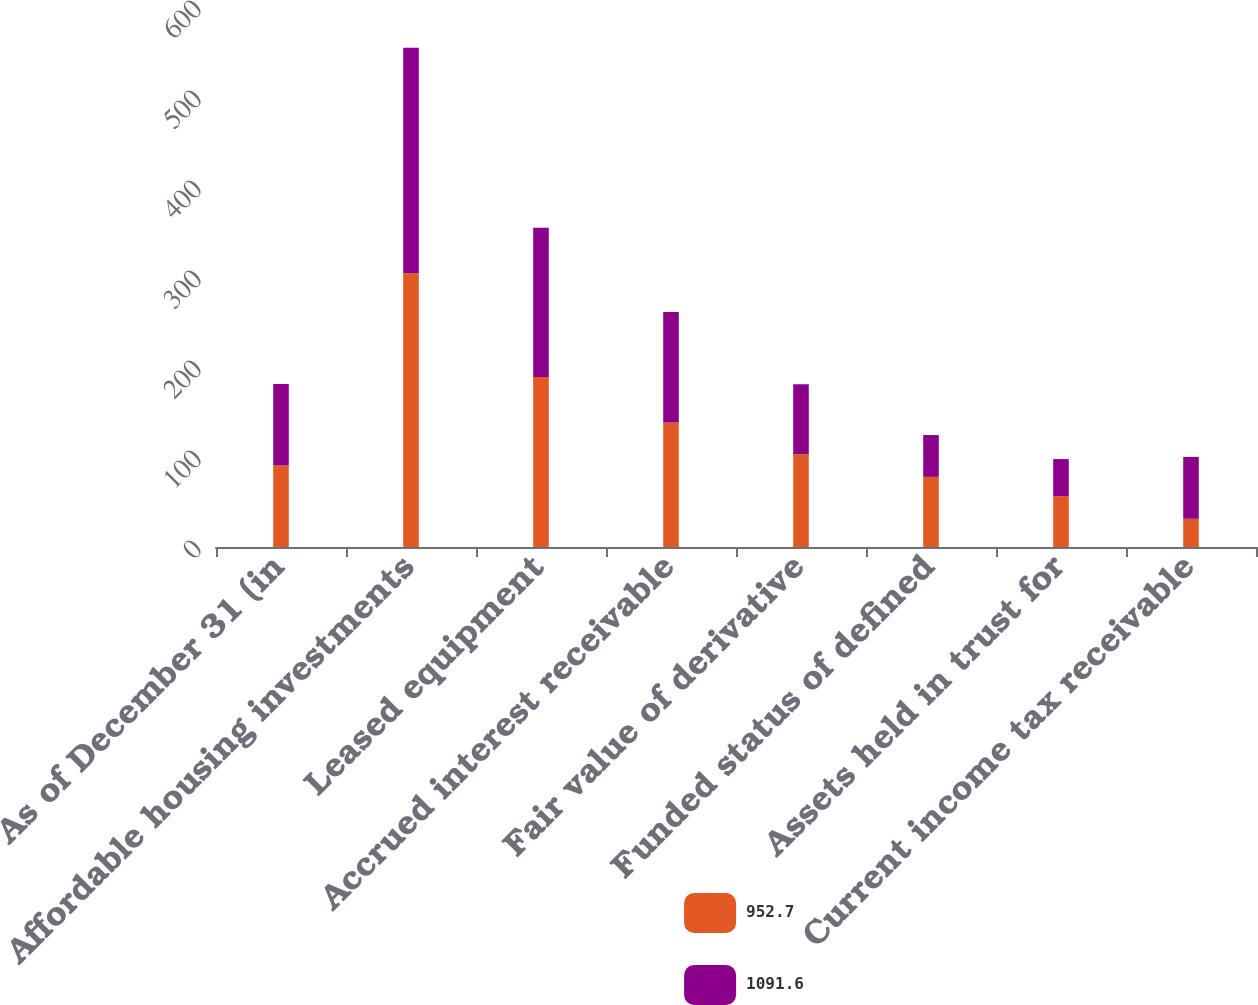Convert chart. <chart><loc_0><loc_0><loc_500><loc_500><stacked_bar_chart><ecel><fcel>As of December 31 (in<fcel>Affordable housing investments<fcel>Leased equipment<fcel>Accrued interest receivable<fcel>Fair value of derivative<fcel>Funded status of defined<fcel>Assets held in trust for<fcel>Current income tax receivable<nl><fcel>952.7<fcel>90.5<fcel>304.1<fcel>189<fcel>138.2<fcel>103<fcel>78<fcel>56.4<fcel>31.4<nl><fcel>1091.6<fcel>90.5<fcel>250.7<fcel>165.8<fcel>122.9<fcel>77.9<fcel>46.4<fcel>41.3<fcel>68.7<nl></chart> 